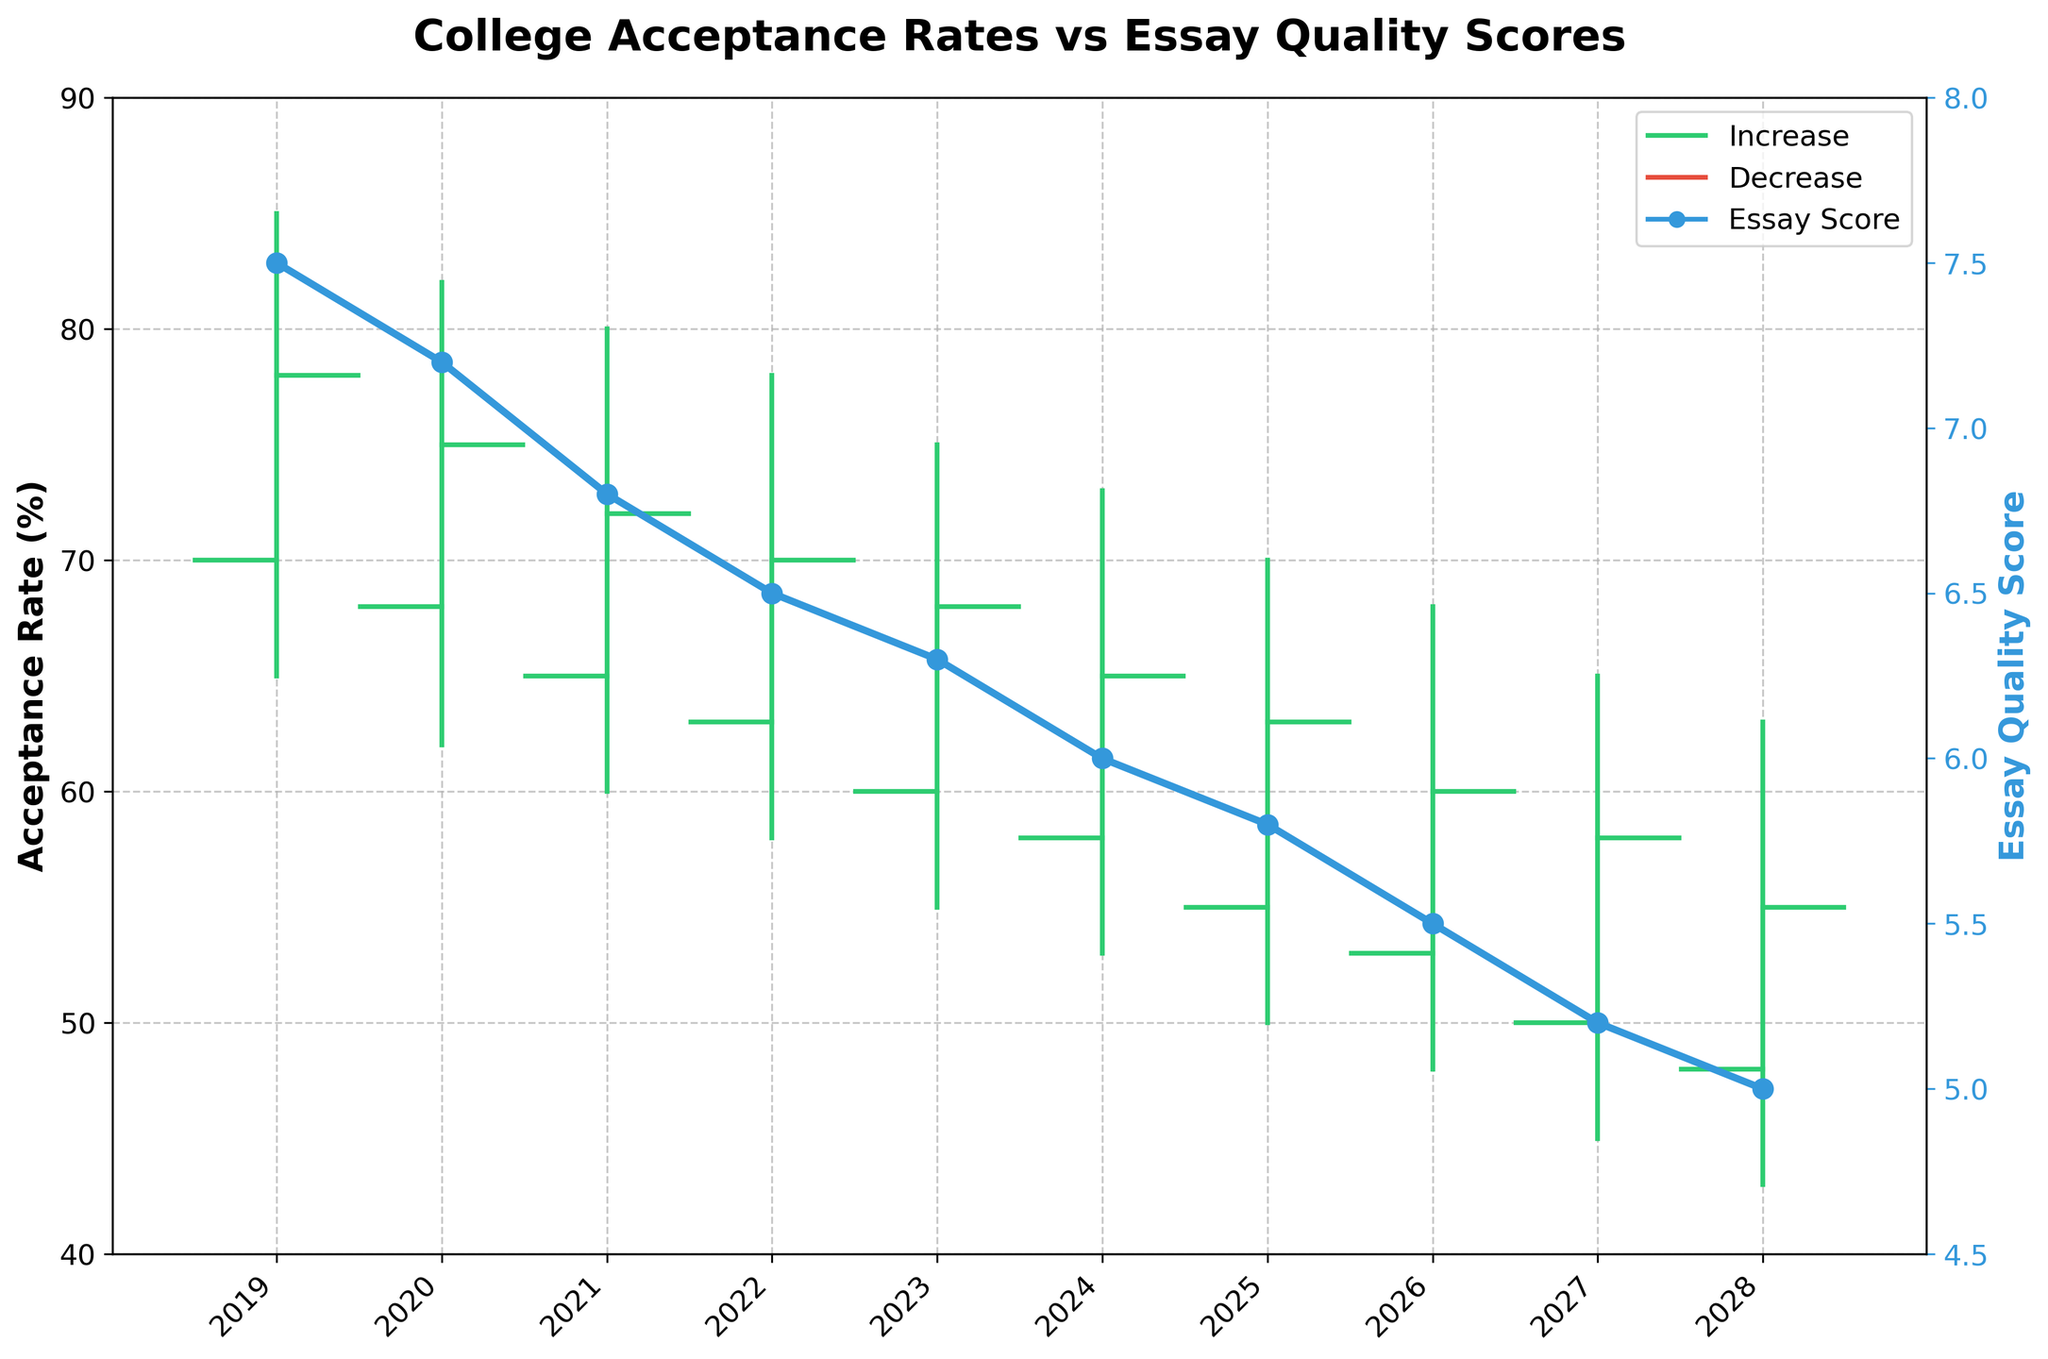What is the trend in college acceptance rates from 2019 to 2028? The trend in college acceptance rates appears to be decreasing from 2019 to 2028. The high values start at 85% in 2019 and drop to 63% in 2028, while the low values drop from 65% to 43% over the same period.
Answer: Decreasing What is the title of the figure? The title of the figure is clearly stated at the top center of the plot.
Answer: College Acceptance Rates vs Essay Quality Scores What color is used to indicate an increase in acceptance rates? The color used to indicate an increase in acceptance rates can be identified by looking at the legend, which shows a green color representing increases.
Answer: Green Which year has the highest essay quality score? The highest essay quality score, as indicated by the line plot with blue markers, is in 2019 with a score of 7.5.
Answer: 2019 What is the lowest acceptance rate recorded in the figure, and in which year does it occur? The lowest acceptance rate recorded in the figure is 43% and it occurs in 2028, as indicated by the bottom whisker of the OHLC chart for that year.
Answer: 43%, 2028 What is the difference between the highest and lowest acceptance rates in 2024? The highest acceptance rate in 2024 is 73%, and the lowest is 53%. The difference can be calculated by subtracting the lowest rate from the highest rate: 73% - 53% = 20%.
Answer: 20% In which years did the acceptance rates decrease compared to the year before? Acceptance rates decrease when the closing value is lower than the opening value. Observing the figure, years with red whiskers indicate a decrease: 2020, 2021, 2022, 2023, 2024, 2025, 2026, 2027, and 2028.
Answer: 2020, 2021, 2022, 2023, 2024, 2025, 2026, 2027,2028 What is the average essay quality score from 2019 to 2028? The average essay quality score can be calculated by summing up all the essay quality scores and dividing by the number of years. (7.5 + 7.2 + 6.8 + 6.5 + 6.3 + 6.0 + 5.8 + 5.5 + 5.2 + 5.0) / 10 = 6.18.
Answer: 6.18 What is the acceptance rate range (difference between high and low) in 2022? In 2022, the highest acceptance rate is 78% and the lowest is 58%. The range is calculated as 78% - 58% = 20%.
Answer: 20% How does the acceptance rate in 2026 compare to 2025? Comparing the closing values of each year, the acceptance rate in 2026 (60%) is lower than in 2025 (63%).
Answer: Lower 